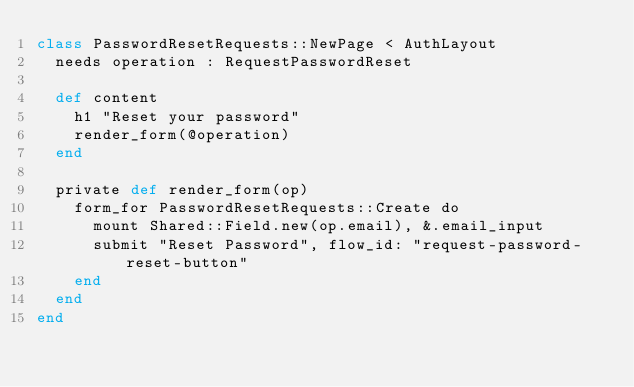<code> <loc_0><loc_0><loc_500><loc_500><_Crystal_>class PasswordResetRequests::NewPage < AuthLayout
  needs operation : RequestPasswordReset

  def content
    h1 "Reset your password"
    render_form(@operation)
  end

  private def render_form(op)
    form_for PasswordResetRequests::Create do
      mount Shared::Field.new(op.email), &.email_input
      submit "Reset Password", flow_id: "request-password-reset-button"
    end
  end
end
</code> 